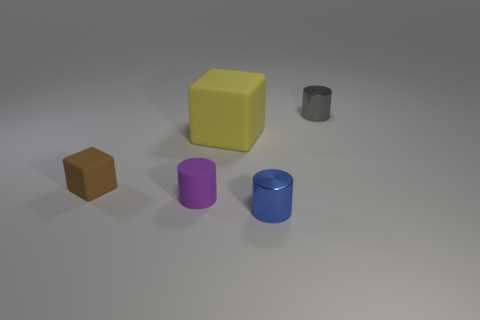Do the block that is in front of the yellow matte object and the large block have the same size?
Provide a succinct answer. No. Is the blue cylinder made of the same material as the small cylinder that is behind the small purple object?
Provide a short and direct response. Yes. What is the material of the tiny cylinder left of the blue object?
Provide a short and direct response. Rubber. Is the number of blocks that are on the left side of the rubber cylinder the same as the number of red blocks?
Your answer should be very brief. No. Are there any other things that have the same size as the gray cylinder?
Give a very brief answer. Yes. What is the material of the thing to the right of the tiny metallic object that is left of the small gray object?
Keep it short and to the point. Metal. What shape is the tiny thing that is right of the yellow thing and in front of the gray metallic object?
Ensure brevity in your answer.  Cylinder. What is the size of the purple rubber thing that is the same shape as the small gray thing?
Your answer should be compact. Small. Are there fewer yellow rubber blocks that are on the right side of the big object than gray cylinders?
Keep it short and to the point. Yes. How big is the metal cylinder that is behind the yellow block?
Your answer should be very brief. Small. 